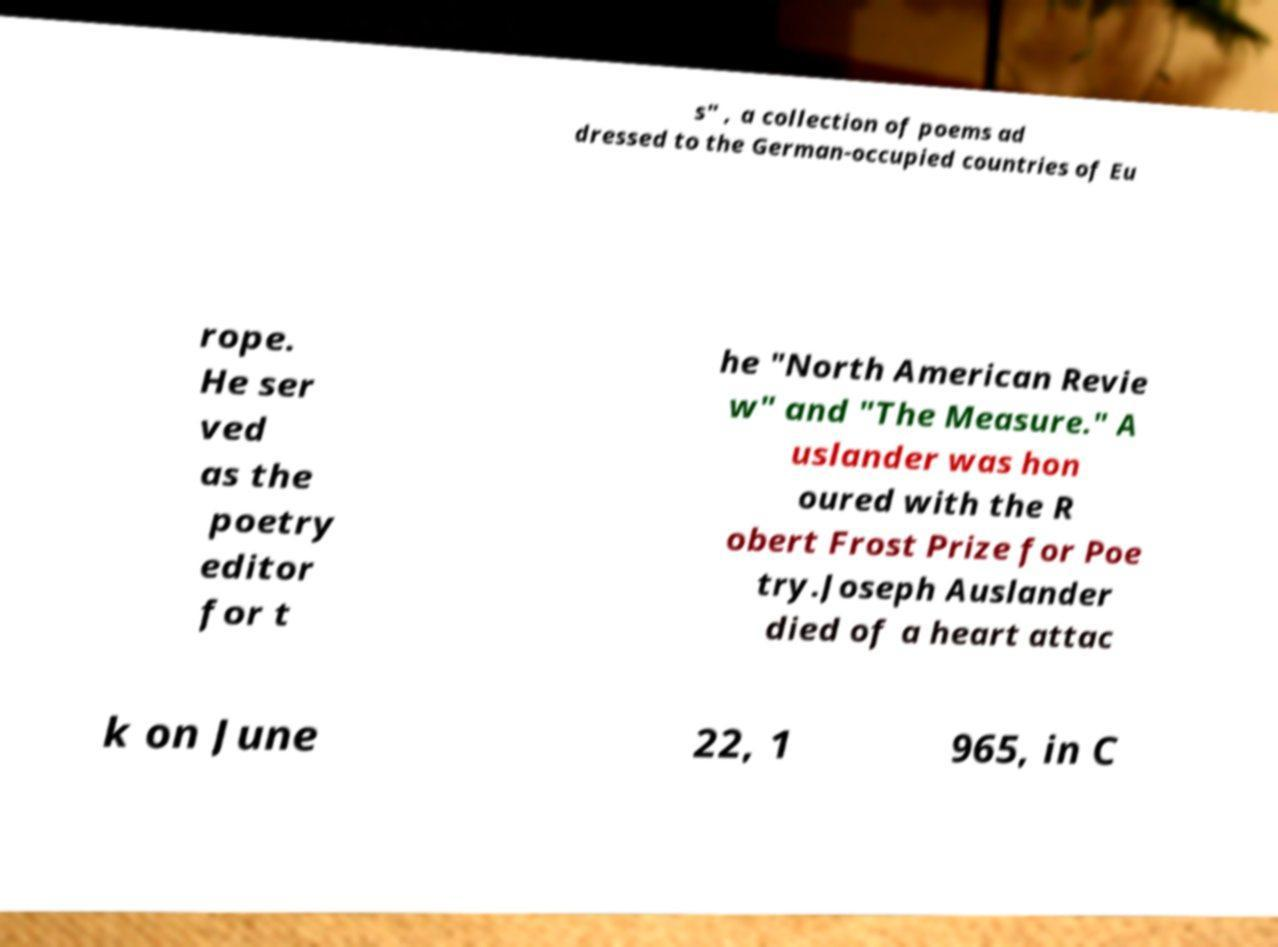Could you extract and type out the text from this image? s" , a collection of poems ad dressed to the German-occupied countries of Eu rope. He ser ved as the poetry editor for t he "North American Revie w" and "The Measure." A uslander was hon oured with the R obert Frost Prize for Poe try.Joseph Auslander died of a heart attac k on June 22, 1 965, in C 